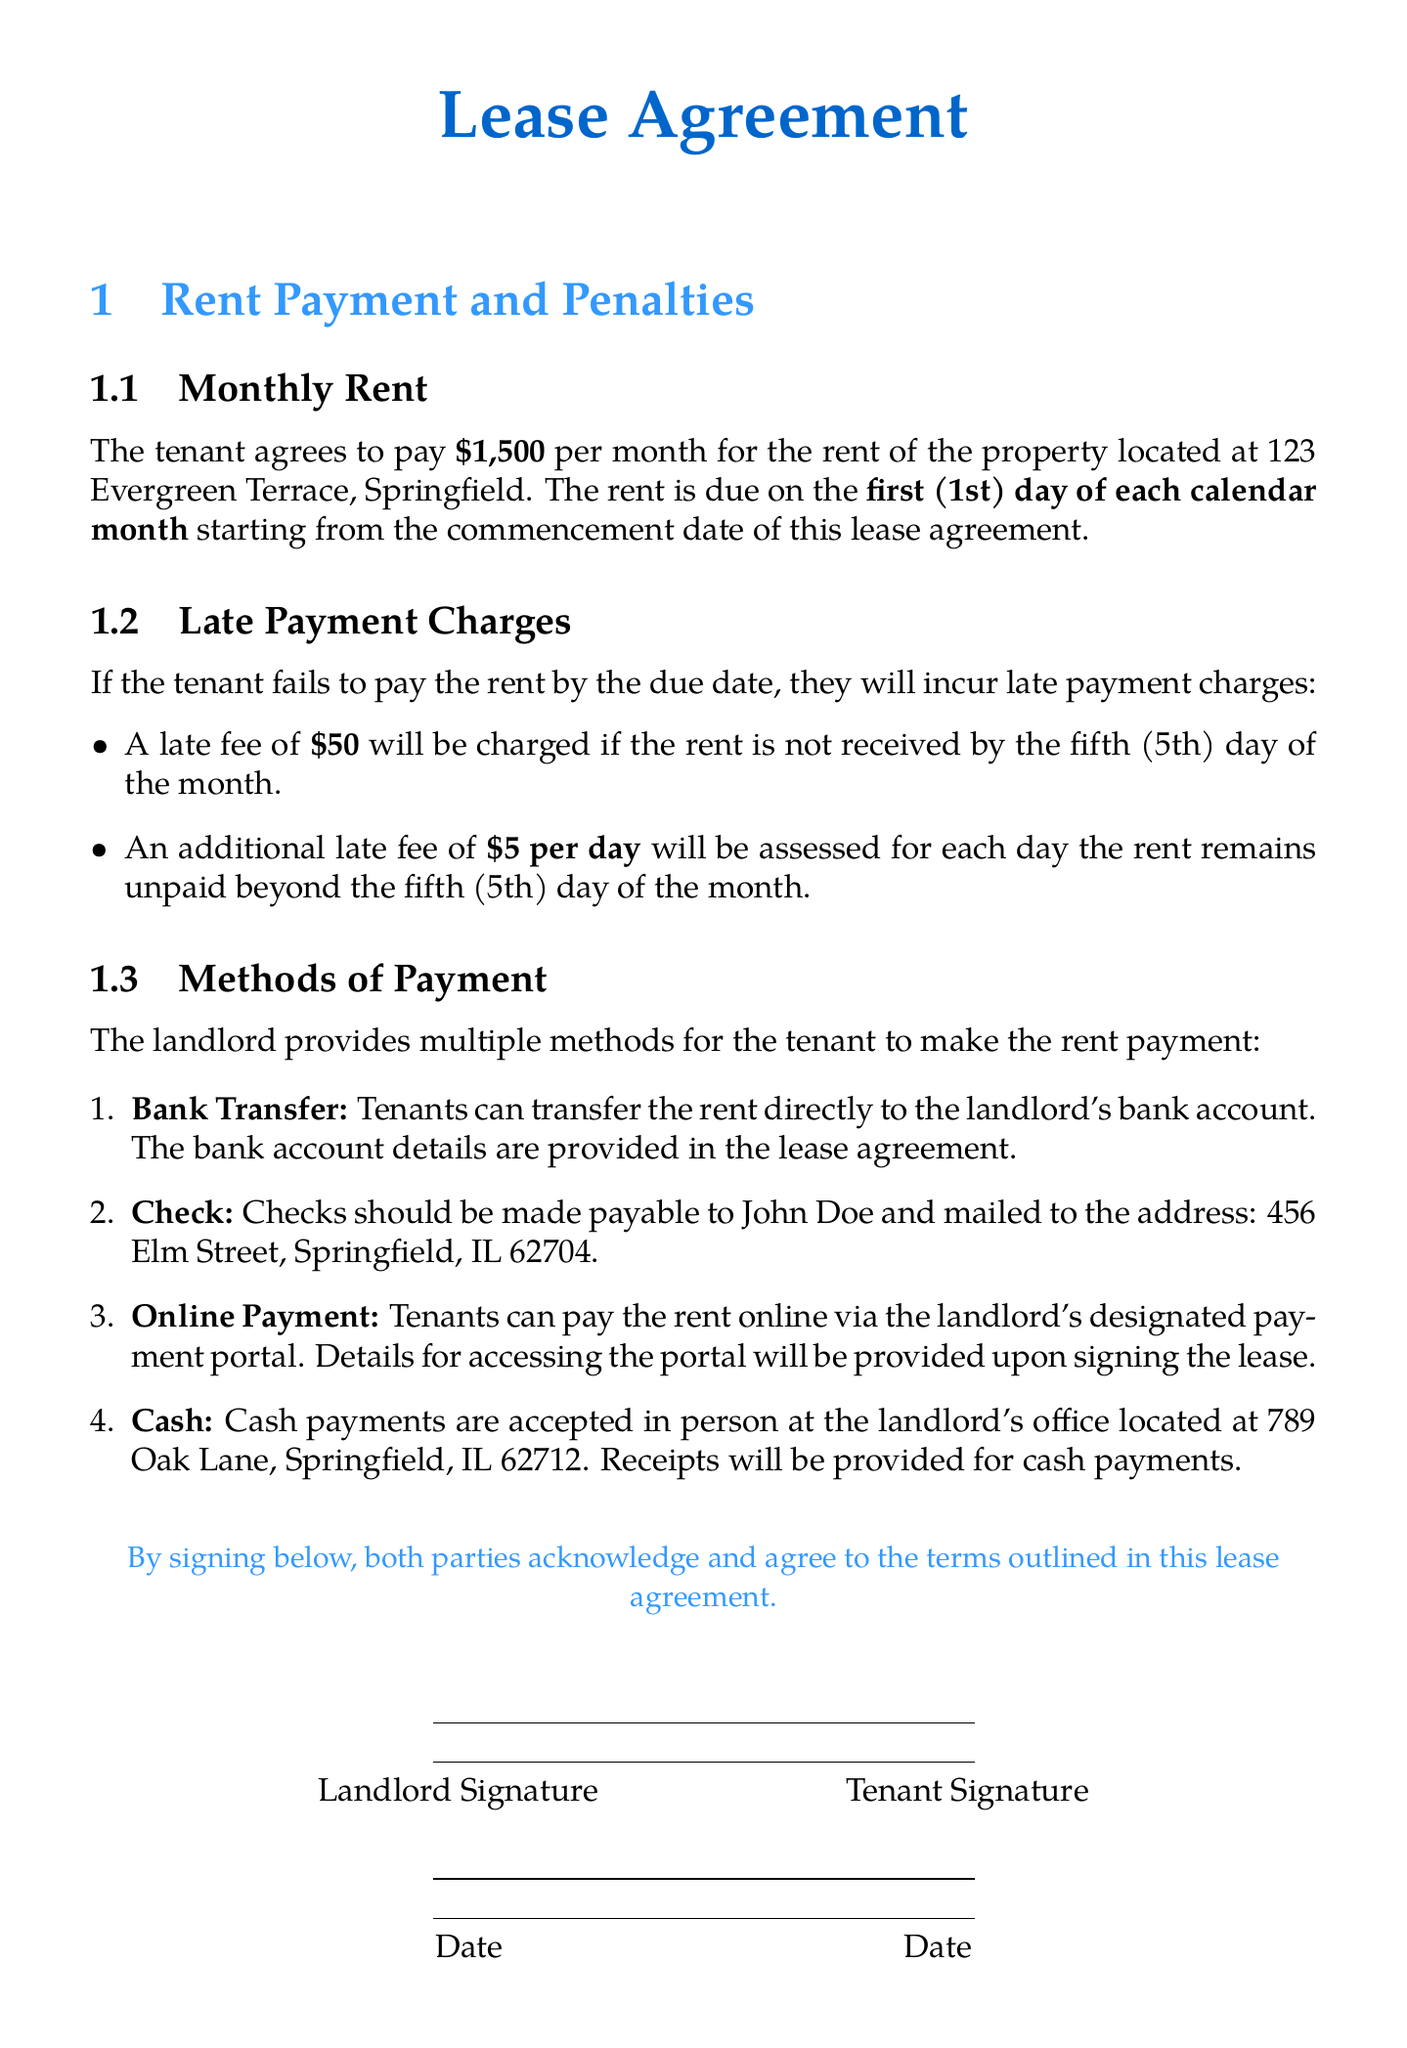what is the monthly rent? The monthly rent specified in the document is the amount the tenant agrees to pay each month.
Answer: $1,500 when is the rent due? The document specifies the date when the rent payment should be made each month.
Answer: first (1st) day of each calendar month what is the late fee after the fifth day? This refers to the additional charge incurred if rent remains unpaid past the specified due date.
Answer: $5 per day who should checks be made payable to? The document identifies the person to whom checks should be addressed for rent payments.
Answer: John Doe where should checks be mailed? The document provides the mailing address for sending checks.
Answer: 456 Elm Street, Springfield, IL 62704 how much is the late fee for the first five days? This is the flat fee charged for late rent payments within the initial grace period.
Answer: $50 what are the accepted methods of payment? This question asks for the various ways tenants can pay rent as listed in the document.
Answer: Bank Transfer, Check, Online Payment, Cash what is the landlord's office address? The document states the location where cash payments can be made in person.
Answer: 789 Oak Lane, Springfield, IL 62712 what must tenants do to pay rent online? This refers to the action required to utilize the online payment method mentioned in the lease agreement.
Answer: Access the landlord's designated payment portal 